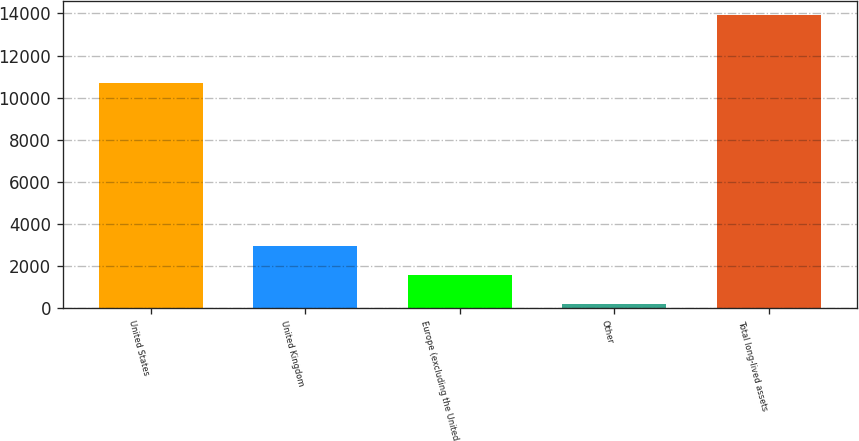Convert chart to OTSL. <chart><loc_0><loc_0><loc_500><loc_500><bar_chart><fcel>United States<fcel>United Kingdom<fcel>Europe (excluding the United<fcel>Other<fcel>Total long-lived assets<nl><fcel>10678<fcel>2941.4<fcel>1570.2<fcel>199<fcel>13911<nl></chart> 